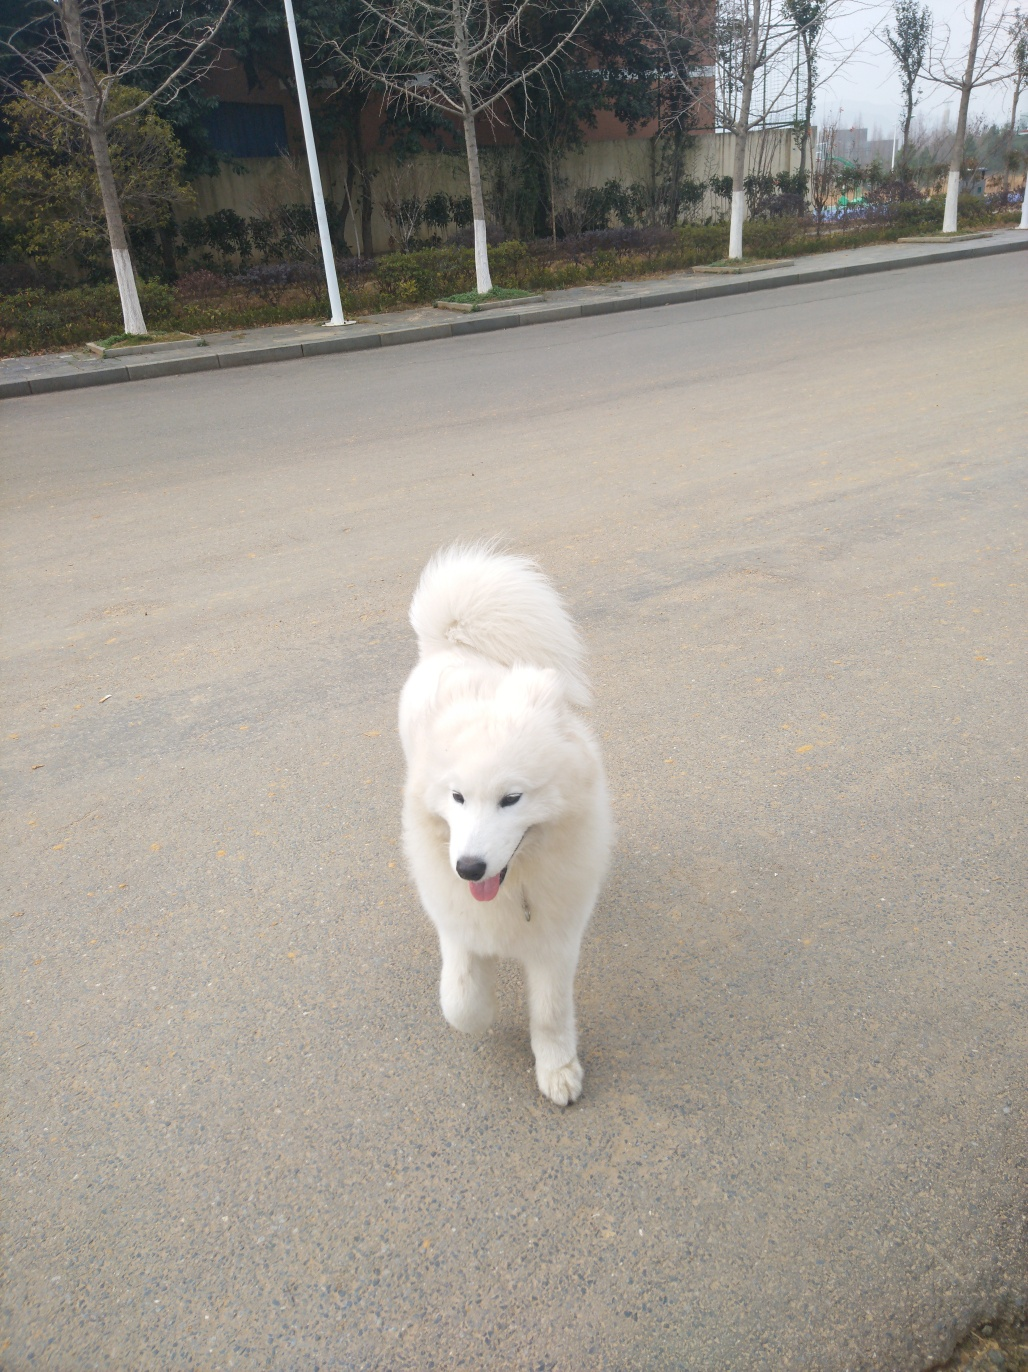Can you describe the dog's exact position in the surrounding environment? The dog is standing on a paved road, positioned in the lower half of the image relative to the camera angle, facing the photographer with a direct gaze. The setting appears to be a roadside with lines of trees and possibly a fenced area in the background. 